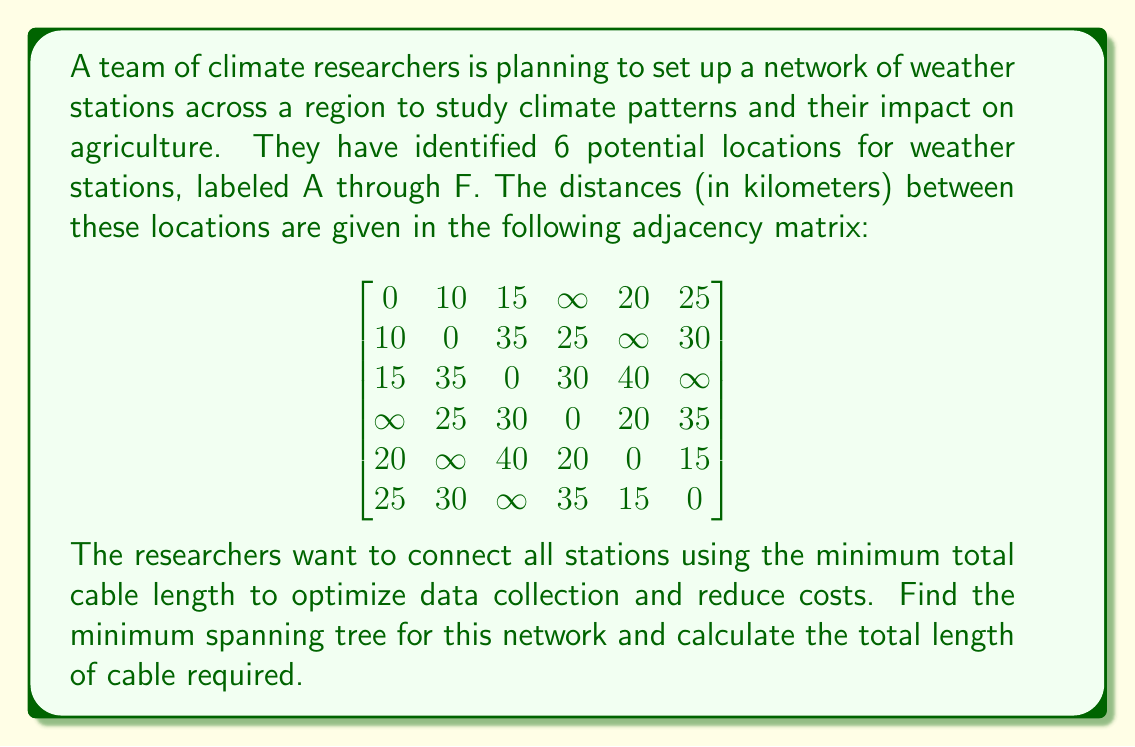Help me with this question. To solve this problem, we'll use Kruskal's algorithm to find the minimum spanning tree (MST) of the given graph. Here's the step-by-step process:

1. Sort all edges in ascending order of weight (distance):
   (A,B): 10, (A,C): 15, (E,F): 15, (A,E): 20, (D,E): 20, (B,D): 25, (A,F): 25, (B,F): 30, (C,D): 30, (D,F): 35

2. Start with an empty set of edges and add edges one by one, ensuring no cycles are formed:

   a. Add (A,B): 10
   b. Add (A,C): 15
   c. Add (E,F): 15
   d. Add (A,E): 20 (connects the two components)
   e. Add (B,D): 25 (connects the last unconnected node)

3. The resulting minimum spanning tree consists of the edges:
   (A,B), (A,C), (E,F), (A,E), (B,D)

4. Calculate the total length of cable required:
   10 + 15 + 15 + 20 + 25 = 85 km

To visualize the MST:

[asy]
unitsize(4cm);
pair A = (0,0), B = (1,0), C = (-0.5,-0.866), D = (1.5,-0.866), E = (0.5,0.866), F = (1,0.866);
draw(A--B--D--E--F, blue);
draw(A--C, blue);
draw(A--E, blue);
dot(A); dot(B); dot(C); dot(D); dot(E); dot(F);
label("A", A, SW);
label("B", B, SE);
label("C", C, SW);
label("D", D, SE);
label("E", E, N);
label("F", F, N);
label("10", (A+B)/2, S);
label("15", (A+C)/2, NW);
label("25", (B+D)/2, SE);
label("20", (A+E)/2, NW);
label("15", (E+F)/2, N);
[/asy]
Answer: The minimum spanning tree consists of the edges (A,B), (A,C), (E,F), (A,E), and (B,D). The total length of cable required is 85 km. 